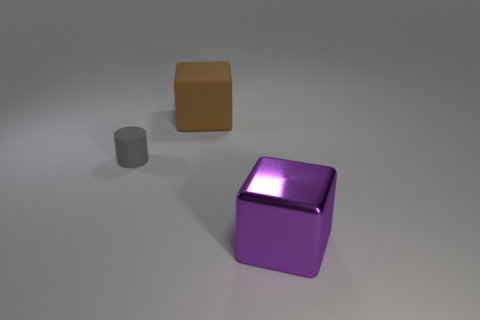Add 1 tiny brown rubber spheres. How many objects exist? 4 Subtract all purple blocks. How many blocks are left? 1 Subtract 0 blue blocks. How many objects are left? 3 Subtract all cylinders. How many objects are left? 2 Subtract 2 blocks. How many blocks are left? 0 Subtract all blue blocks. Subtract all purple cylinders. How many blocks are left? 2 Subtract all small rubber cylinders. Subtract all shiny cubes. How many objects are left? 1 Add 3 big purple blocks. How many big purple blocks are left? 4 Add 1 large blue rubber spheres. How many large blue rubber spheres exist? 1 